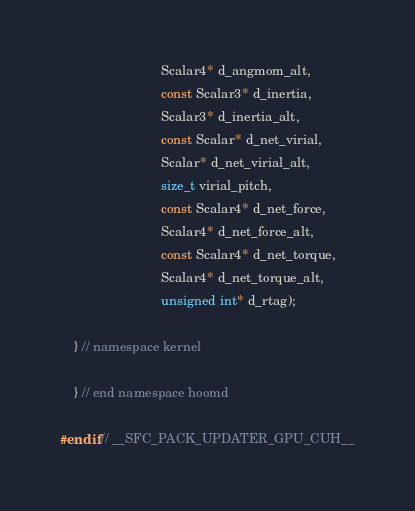<code> <loc_0><loc_0><loc_500><loc_500><_Cuda_>                            Scalar4* d_angmom_alt,
                            const Scalar3* d_inertia,
                            Scalar3* d_inertia_alt,
                            const Scalar* d_net_virial,
                            Scalar* d_net_virial_alt,
                            size_t virial_pitch,
                            const Scalar4* d_net_force,
                            Scalar4* d_net_force_alt,
                            const Scalar4* d_net_torque,
                            Scalar4* d_net_torque_alt,
                            unsigned int* d_rtag);

    } // namespace kernel

    } // end namespace hoomd

#endif // __SFC_PACK_UPDATER_GPU_CUH__
</code> 